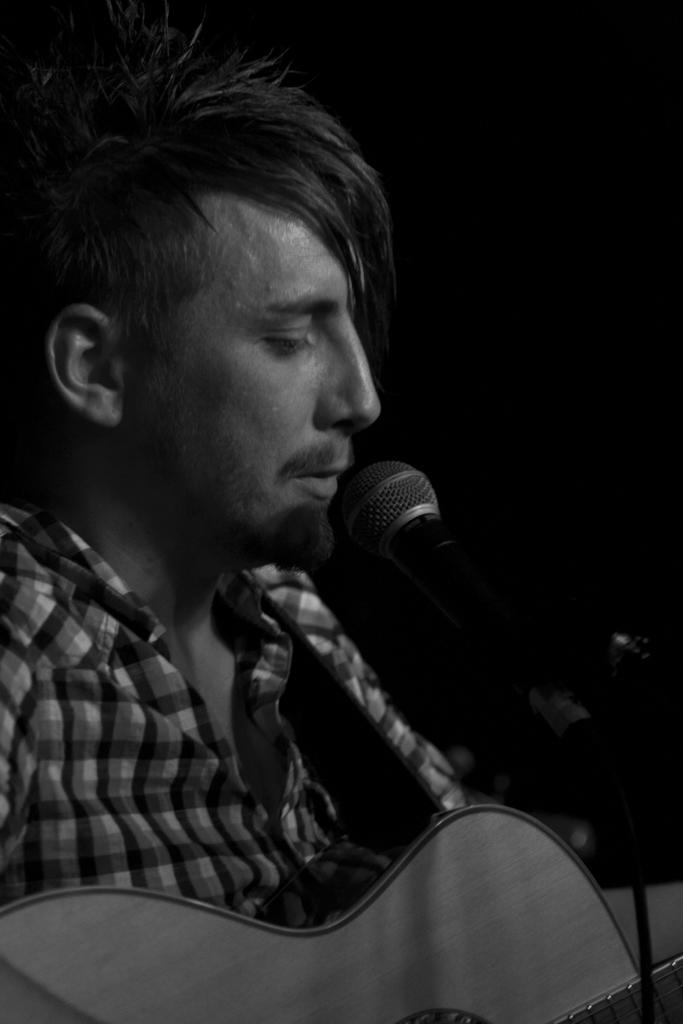What is the person in the image doing? The person is playing a guitar and singing. What object is the person using to amplify their voice? There is a microphone in the image. What type of baseball card can be seen in the image? There is no baseball card present in the image. How does the friction between the guitar strings and the guitar affect the sound produced? The image does not provide enough information to determine the effect of friction on the sound produced by the guitar. 